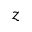<formula> <loc_0><loc_0><loc_500><loc_500>z</formula> 